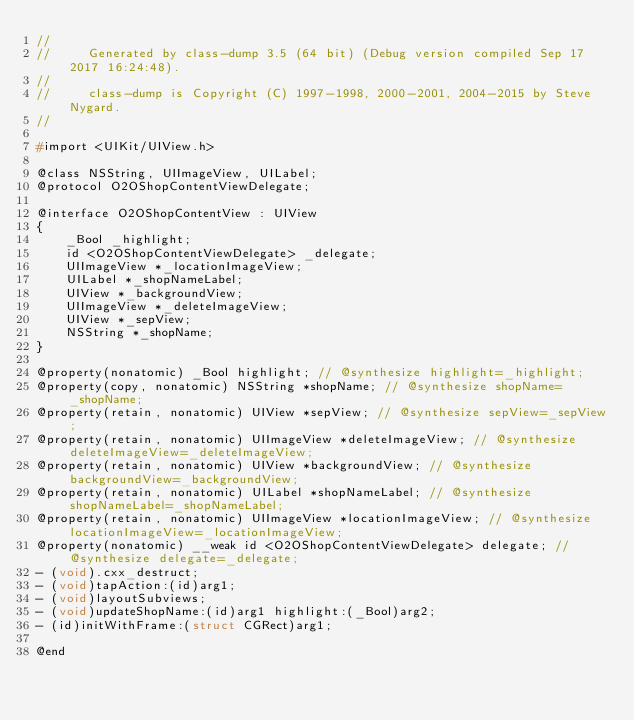<code> <loc_0><loc_0><loc_500><loc_500><_C_>//
//     Generated by class-dump 3.5 (64 bit) (Debug version compiled Sep 17 2017 16:24:48).
//
//     class-dump is Copyright (C) 1997-1998, 2000-2001, 2004-2015 by Steve Nygard.
//

#import <UIKit/UIView.h>

@class NSString, UIImageView, UILabel;
@protocol O2OShopContentViewDelegate;

@interface O2OShopContentView : UIView
{
    _Bool _highlight;
    id <O2OShopContentViewDelegate> _delegate;
    UIImageView *_locationImageView;
    UILabel *_shopNameLabel;
    UIView *_backgroundView;
    UIImageView *_deleteImageView;
    UIView *_sepView;
    NSString *_shopName;
}

@property(nonatomic) _Bool highlight; // @synthesize highlight=_highlight;
@property(copy, nonatomic) NSString *shopName; // @synthesize shopName=_shopName;
@property(retain, nonatomic) UIView *sepView; // @synthesize sepView=_sepView;
@property(retain, nonatomic) UIImageView *deleteImageView; // @synthesize deleteImageView=_deleteImageView;
@property(retain, nonatomic) UIView *backgroundView; // @synthesize backgroundView=_backgroundView;
@property(retain, nonatomic) UILabel *shopNameLabel; // @synthesize shopNameLabel=_shopNameLabel;
@property(retain, nonatomic) UIImageView *locationImageView; // @synthesize locationImageView=_locationImageView;
@property(nonatomic) __weak id <O2OShopContentViewDelegate> delegate; // @synthesize delegate=_delegate;
- (void).cxx_destruct;
- (void)tapAction:(id)arg1;
- (void)layoutSubviews;
- (void)updateShopName:(id)arg1 highlight:(_Bool)arg2;
- (id)initWithFrame:(struct CGRect)arg1;

@end

</code> 